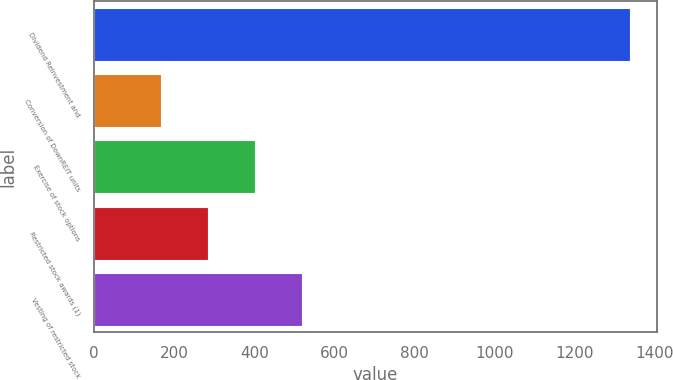Convert chart to OTSL. <chart><loc_0><loc_0><loc_500><loc_500><bar_chart><fcel>Dividend Reinvestment and<fcel>Conversion of DownREIT units<fcel>Exercise of stock options<fcel>Restricted stock awards (1)<fcel>Vesting of restricted stock<nl><fcel>1338<fcel>167<fcel>401.2<fcel>284.1<fcel>518.3<nl></chart> 